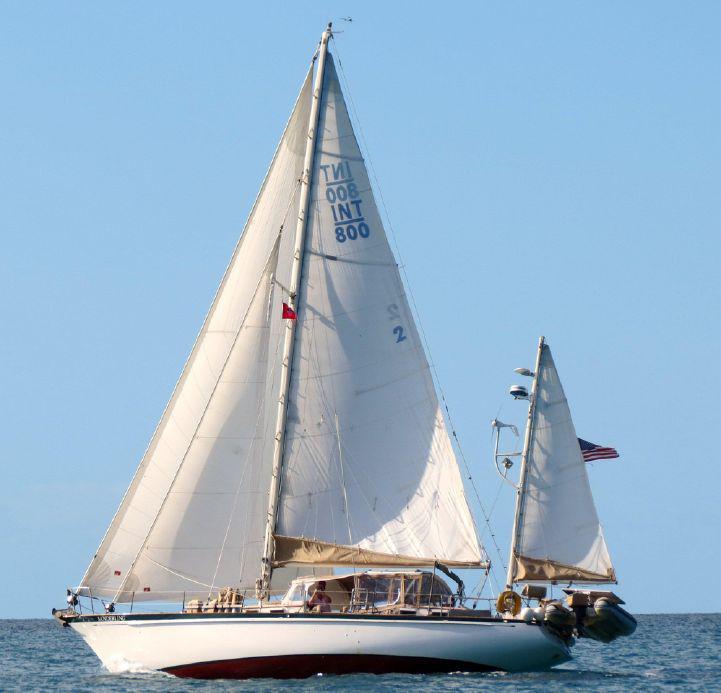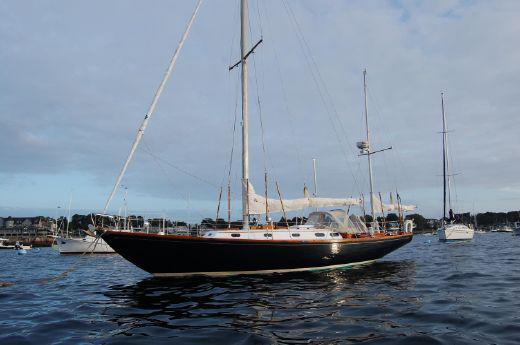The first image is the image on the left, the second image is the image on the right. Given the left and right images, does the statement "There are exactly four visible sails in the image on the left." hold true? Answer yes or no. No. 